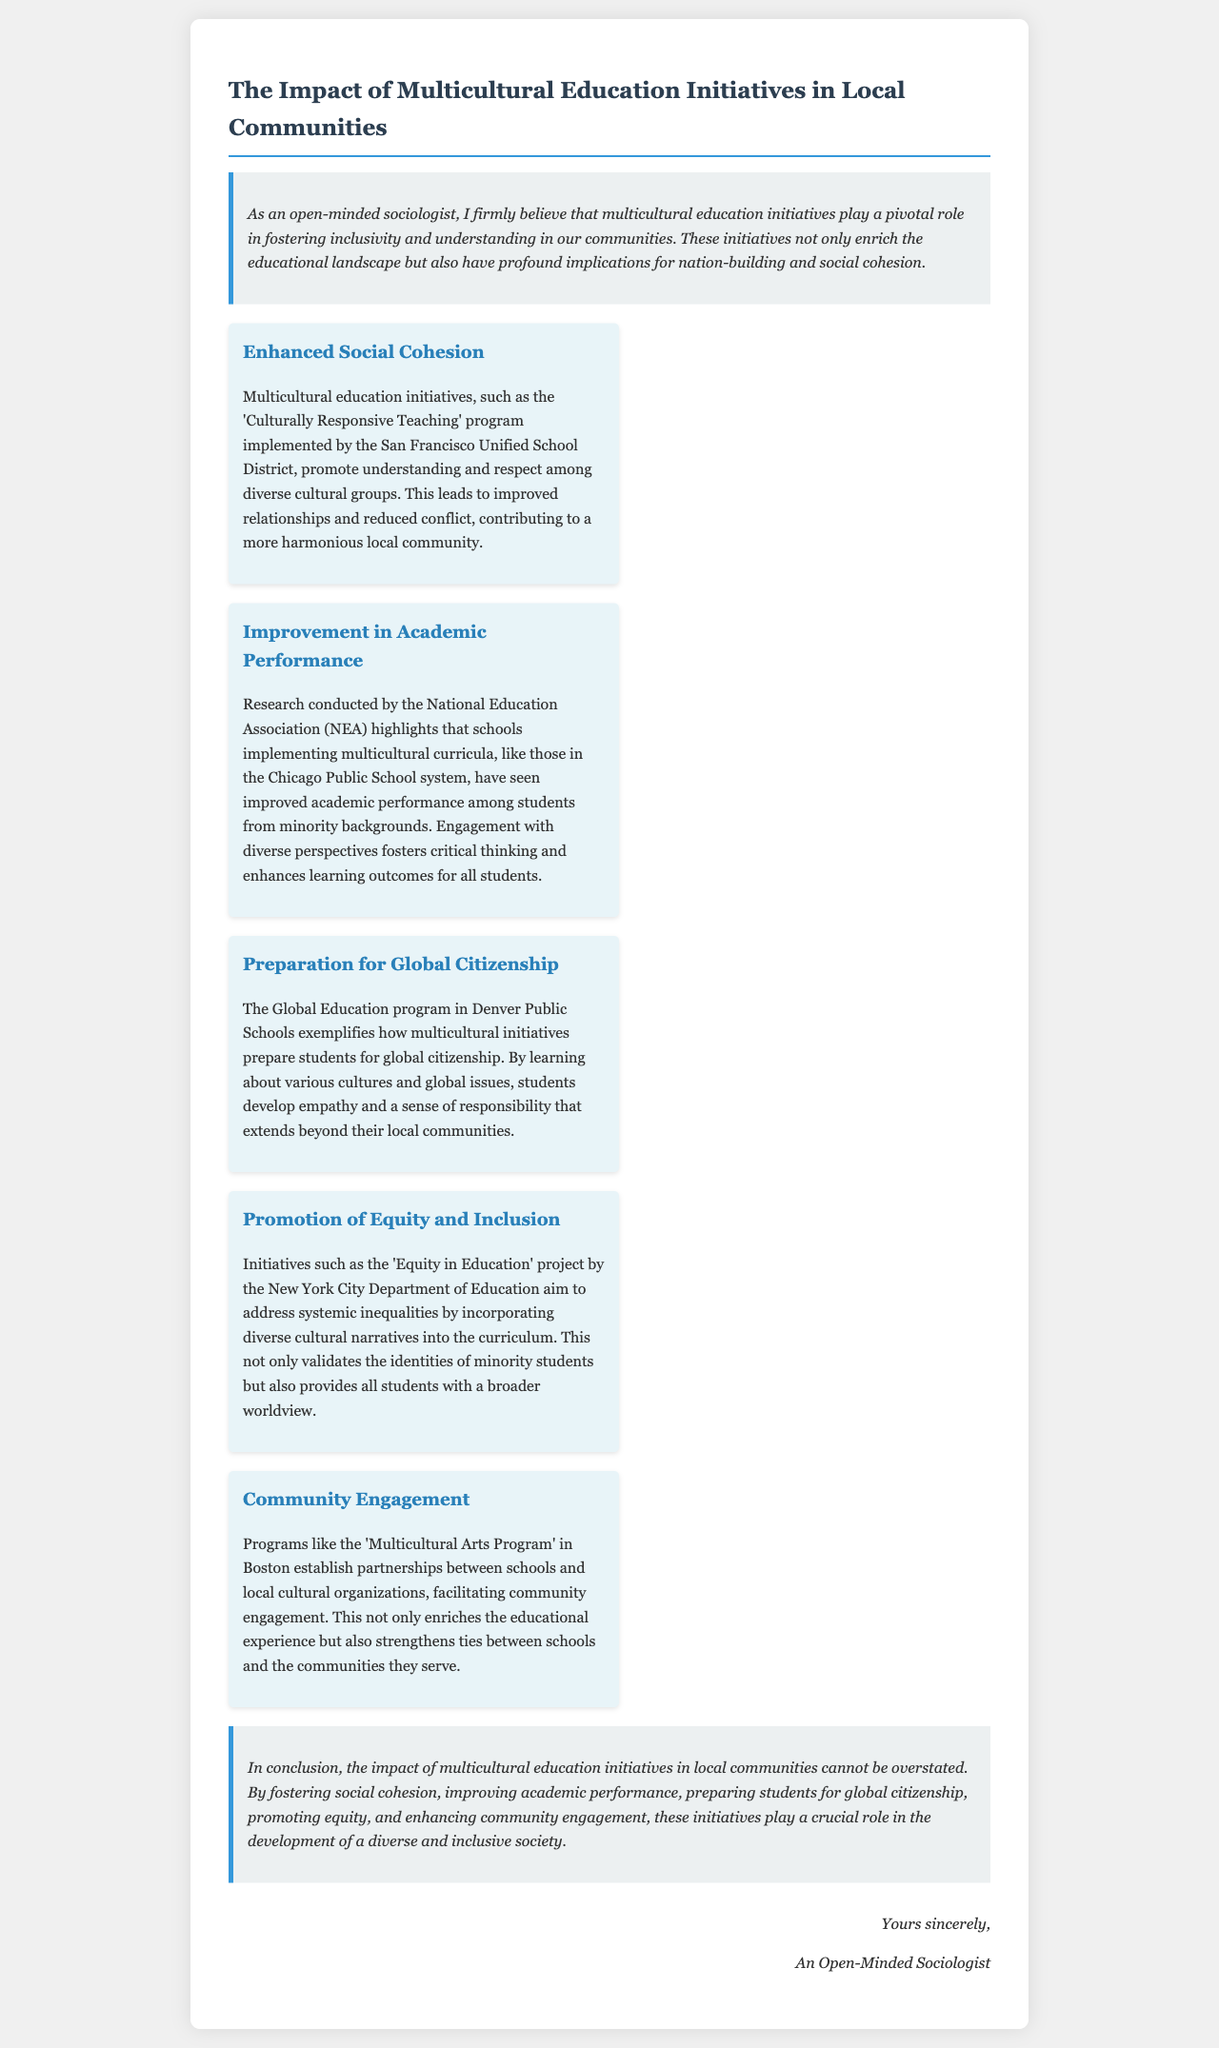What is the title of the document? The title is prominently displayed at the beginning of the document and states the topic of the letter.
Answer: The Impact of Multicultural Education Initiatives in Local Communities What initiative is implemented by the San Francisco Unified School District? The text specifies the name of the program that enhances social cohesion in the community.
Answer: Culturally Responsive Teaching Which research organization highlighted improvements in academic performance? The document mentions this organization in relation to the successful implementation of multicultural curricula.
Answer: National Education Association What city is associated with the 'Equity in Education' project? The document identifies the location where this initiative is being carried out to promote equity and inclusion.
Answer: New York City How does the Global Education program in Denver Public Schools benefit students? This question pertains to how this program prepares students for a specific role related to global understanding.
Answer: Global citizenship What type of program is established in Boston to enhance community engagement? The letter mentions a specific program that connects schools with local cultural organizations in Boston.
Answer: Multicultural Arts Program What is the primary goal of multicultural education initiatives according to the letter? The document outlines the overarching aim of these initiatives in relation to community and society.
Answer: Fostering inclusivity and understanding Who is the letter addressed to? This question pertains to the signature section of the letter, identifying the author as a certain type of individual.
Answer: An Open-Minded Sociologist 